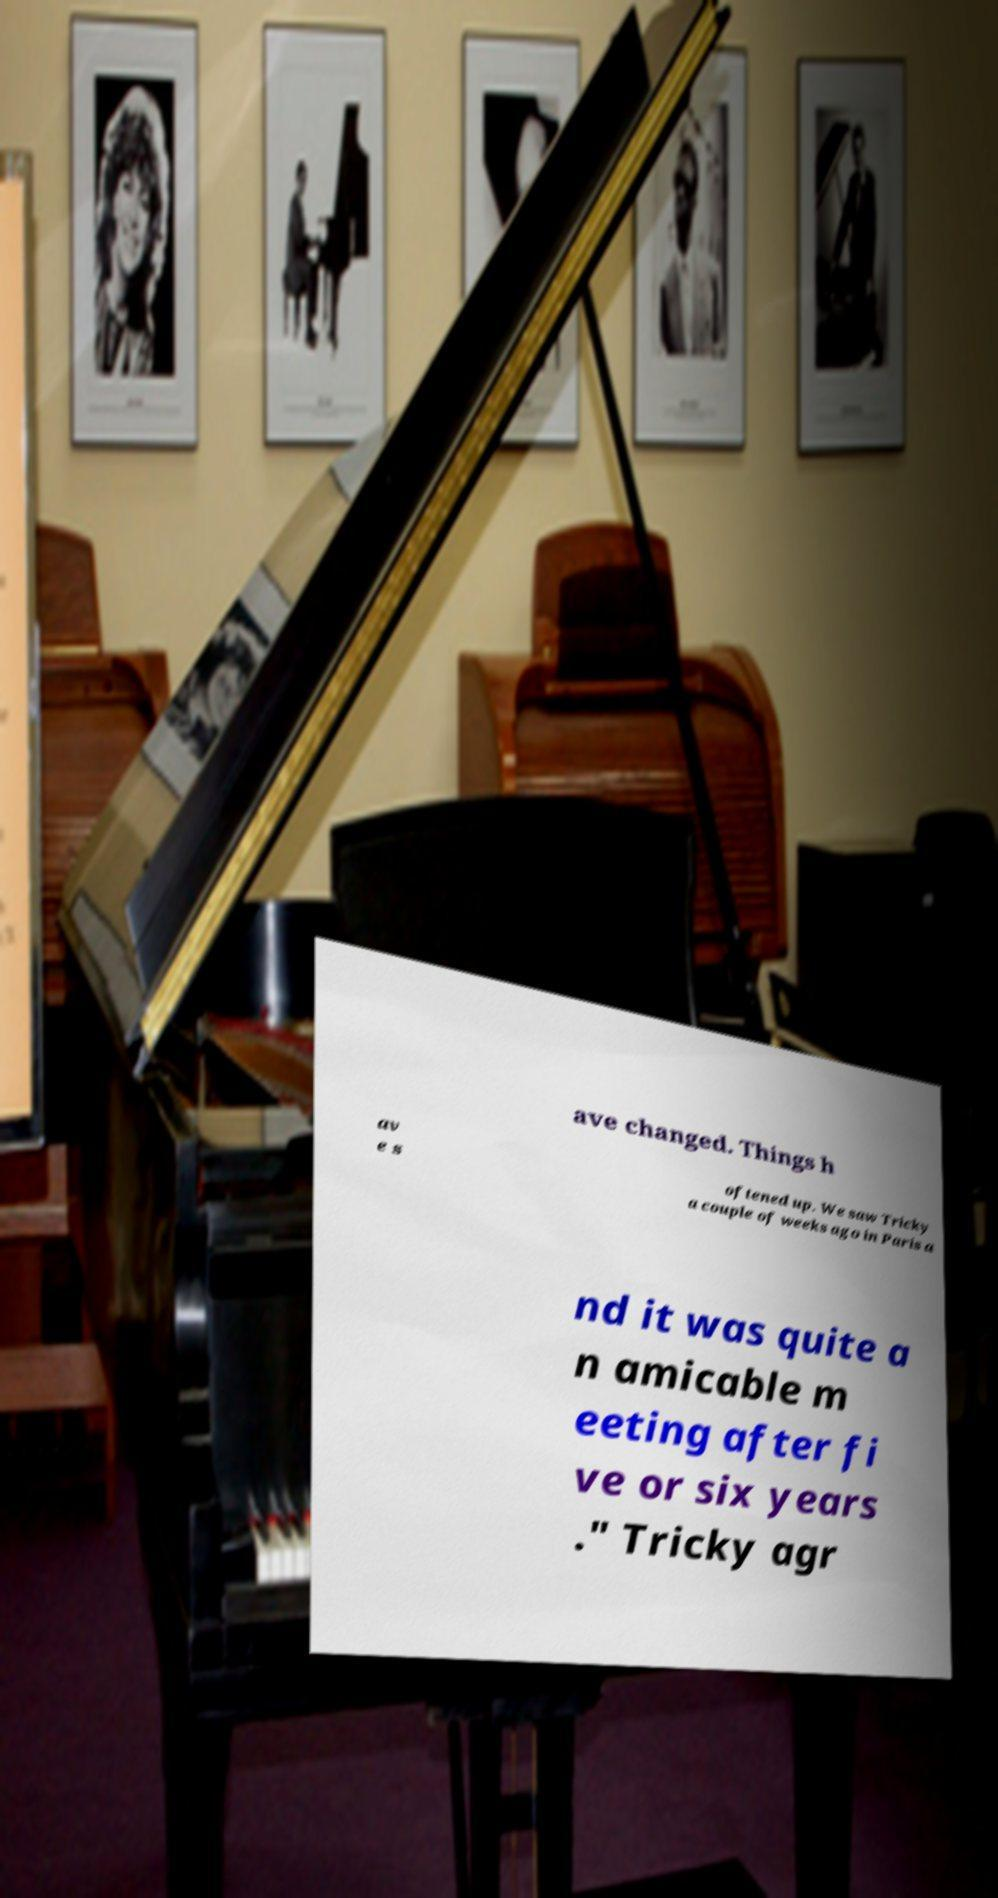Could you extract and type out the text from this image? ave changed. Things h av e s oftened up. We saw Tricky a couple of weeks ago in Paris a nd it was quite a n amicable m eeting after fi ve or six years ." Tricky agr 